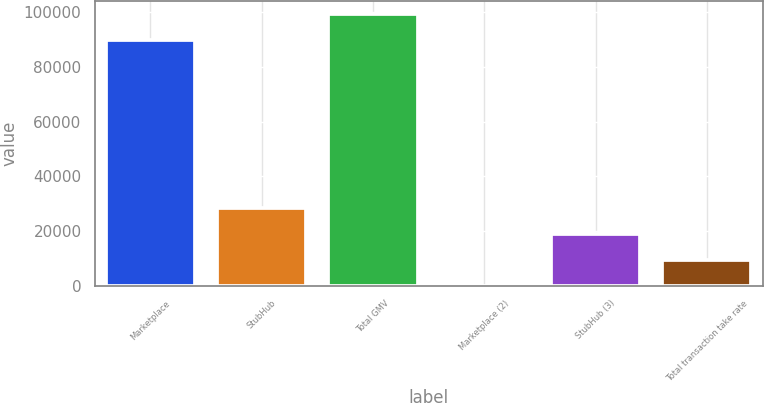Convert chart to OTSL. <chart><loc_0><loc_0><loc_500><loc_500><bar_chart><fcel>Marketplace<fcel>StubHub<fcel>Total GMV<fcel>Marketplace (2)<fcel>StubHub (3)<fcel>Total transaction take rate<nl><fcel>89829<fcel>28379.8<fcel>99286.2<fcel>8.25<fcel>18922.6<fcel>9465.43<nl></chart> 